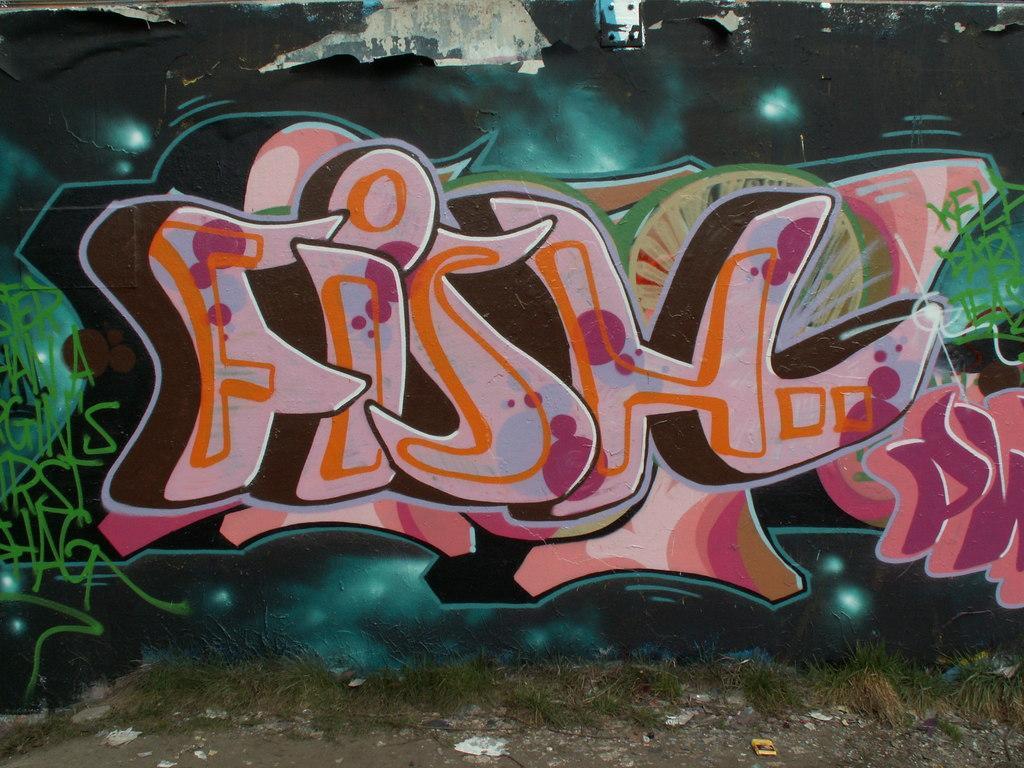Could you give a brief overview of what you see in this image? In this picture we can see some grass and a few objects on the path. There is some text and painting is visible on a wall. 